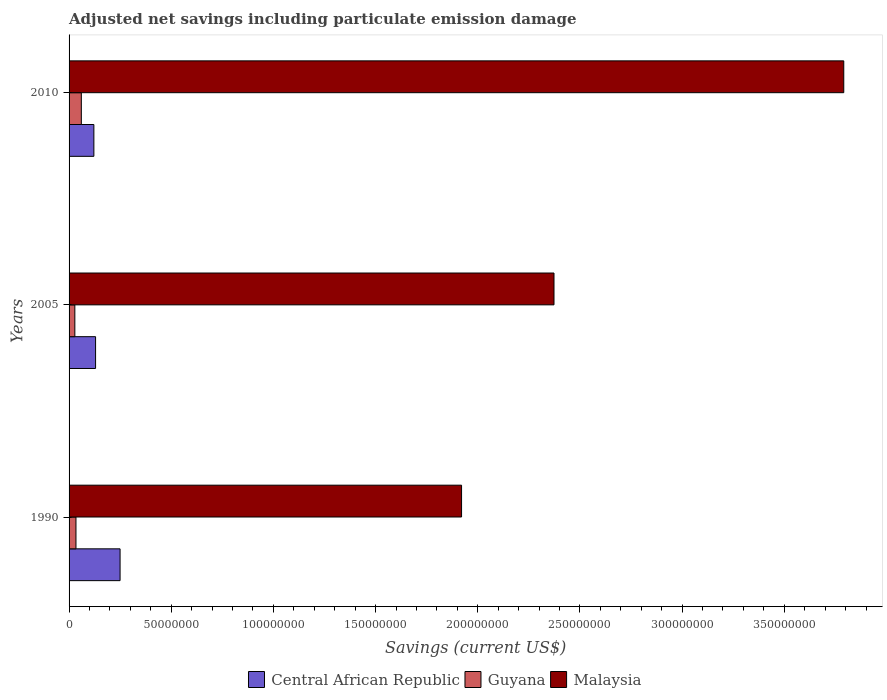How many groups of bars are there?
Your answer should be compact. 3. What is the net savings in Guyana in 2010?
Your answer should be compact. 6.00e+06. Across all years, what is the maximum net savings in Malaysia?
Keep it short and to the point. 3.79e+08. Across all years, what is the minimum net savings in Central African Republic?
Offer a very short reply. 1.21e+07. In which year was the net savings in Guyana minimum?
Offer a terse response. 2005. What is the total net savings in Malaysia in the graph?
Your answer should be very brief. 8.09e+08. What is the difference between the net savings in Central African Republic in 2005 and that in 2010?
Offer a terse response. 8.31e+05. What is the difference between the net savings in Guyana in 1990 and the net savings in Malaysia in 2010?
Offer a terse response. -3.76e+08. What is the average net savings in Guyana per year?
Offer a terse response. 4.07e+06. In the year 1990, what is the difference between the net savings in Guyana and net savings in Central African Republic?
Your answer should be very brief. -2.16e+07. What is the ratio of the net savings in Malaysia in 1990 to that in 2005?
Offer a terse response. 0.81. Is the net savings in Malaysia in 1990 less than that in 2005?
Make the answer very short. Yes. What is the difference between the highest and the second highest net savings in Malaysia?
Your response must be concise. 1.42e+08. What is the difference between the highest and the lowest net savings in Central African Republic?
Your answer should be very brief. 1.28e+07. In how many years, is the net savings in Guyana greater than the average net savings in Guyana taken over all years?
Offer a terse response. 1. Is the sum of the net savings in Malaysia in 2005 and 2010 greater than the maximum net savings in Guyana across all years?
Make the answer very short. Yes. What does the 2nd bar from the top in 2010 represents?
Keep it short and to the point. Guyana. What does the 2nd bar from the bottom in 1990 represents?
Keep it short and to the point. Guyana. Are all the bars in the graph horizontal?
Make the answer very short. Yes. How many years are there in the graph?
Your answer should be compact. 3. What is the difference between two consecutive major ticks on the X-axis?
Give a very brief answer. 5.00e+07. Does the graph contain any zero values?
Ensure brevity in your answer.  No. Does the graph contain grids?
Ensure brevity in your answer.  No. What is the title of the graph?
Your answer should be very brief. Adjusted net savings including particulate emission damage. Does "New Caledonia" appear as one of the legend labels in the graph?
Ensure brevity in your answer.  No. What is the label or title of the X-axis?
Keep it short and to the point. Savings (current US$). What is the label or title of the Y-axis?
Offer a very short reply. Years. What is the Savings (current US$) in Central African Republic in 1990?
Give a very brief answer. 2.50e+07. What is the Savings (current US$) in Guyana in 1990?
Give a very brief answer. 3.37e+06. What is the Savings (current US$) of Malaysia in 1990?
Provide a succinct answer. 1.92e+08. What is the Savings (current US$) in Central African Republic in 2005?
Provide a short and direct response. 1.30e+07. What is the Savings (current US$) in Guyana in 2005?
Keep it short and to the point. 2.82e+06. What is the Savings (current US$) in Malaysia in 2005?
Make the answer very short. 2.37e+08. What is the Savings (current US$) of Central African Republic in 2010?
Give a very brief answer. 1.21e+07. What is the Savings (current US$) of Guyana in 2010?
Your answer should be compact. 6.00e+06. What is the Savings (current US$) in Malaysia in 2010?
Provide a succinct answer. 3.79e+08. Across all years, what is the maximum Savings (current US$) of Central African Republic?
Ensure brevity in your answer.  2.50e+07. Across all years, what is the maximum Savings (current US$) in Guyana?
Give a very brief answer. 6.00e+06. Across all years, what is the maximum Savings (current US$) in Malaysia?
Give a very brief answer. 3.79e+08. Across all years, what is the minimum Savings (current US$) of Central African Republic?
Offer a terse response. 1.21e+07. Across all years, what is the minimum Savings (current US$) of Guyana?
Your answer should be very brief. 2.82e+06. Across all years, what is the minimum Savings (current US$) in Malaysia?
Provide a succinct answer. 1.92e+08. What is the total Savings (current US$) of Central African Republic in the graph?
Offer a very short reply. 5.01e+07. What is the total Savings (current US$) in Guyana in the graph?
Provide a succinct answer. 1.22e+07. What is the total Savings (current US$) in Malaysia in the graph?
Offer a very short reply. 8.09e+08. What is the difference between the Savings (current US$) of Central African Republic in 1990 and that in 2005?
Provide a short and direct response. 1.20e+07. What is the difference between the Savings (current US$) of Guyana in 1990 and that in 2005?
Keep it short and to the point. 5.50e+05. What is the difference between the Savings (current US$) in Malaysia in 1990 and that in 2005?
Keep it short and to the point. -4.52e+07. What is the difference between the Savings (current US$) in Central African Republic in 1990 and that in 2010?
Your answer should be very brief. 1.28e+07. What is the difference between the Savings (current US$) in Guyana in 1990 and that in 2010?
Provide a succinct answer. -2.62e+06. What is the difference between the Savings (current US$) in Malaysia in 1990 and that in 2010?
Your response must be concise. -1.87e+08. What is the difference between the Savings (current US$) of Central African Republic in 2005 and that in 2010?
Provide a short and direct response. 8.31e+05. What is the difference between the Savings (current US$) in Guyana in 2005 and that in 2010?
Your response must be concise. -3.17e+06. What is the difference between the Savings (current US$) of Malaysia in 2005 and that in 2010?
Offer a very short reply. -1.42e+08. What is the difference between the Savings (current US$) of Central African Republic in 1990 and the Savings (current US$) of Guyana in 2005?
Provide a short and direct response. 2.21e+07. What is the difference between the Savings (current US$) of Central African Republic in 1990 and the Savings (current US$) of Malaysia in 2005?
Provide a succinct answer. -2.12e+08. What is the difference between the Savings (current US$) in Guyana in 1990 and the Savings (current US$) in Malaysia in 2005?
Provide a succinct answer. -2.34e+08. What is the difference between the Savings (current US$) in Central African Republic in 1990 and the Savings (current US$) in Guyana in 2010?
Ensure brevity in your answer.  1.90e+07. What is the difference between the Savings (current US$) of Central African Republic in 1990 and the Savings (current US$) of Malaysia in 2010?
Make the answer very short. -3.54e+08. What is the difference between the Savings (current US$) of Guyana in 1990 and the Savings (current US$) of Malaysia in 2010?
Your answer should be compact. -3.76e+08. What is the difference between the Savings (current US$) of Central African Republic in 2005 and the Savings (current US$) of Guyana in 2010?
Offer a terse response. 6.97e+06. What is the difference between the Savings (current US$) in Central African Republic in 2005 and the Savings (current US$) in Malaysia in 2010?
Your answer should be very brief. -3.66e+08. What is the difference between the Savings (current US$) in Guyana in 2005 and the Savings (current US$) in Malaysia in 2010?
Your response must be concise. -3.76e+08. What is the average Savings (current US$) in Central African Republic per year?
Your response must be concise. 1.67e+07. What is the average Savings (current US$) in Guyana per year?
Provide a succinct answer. 4.07e+06. What is the average Savings (current US$) in Malaysia per year?
Offer a very short reply. 2.70e+08. In the year 1990, what is the difference between the Savings (current US$) in Central African Republic and Savings (current US$) in Guyana?
Provide a succinct answer. 2.16e+07. In the year 1990, what is the difference between the Savings (current US$) in Central African Republic and Savings (current US$) in Malaysia?
Ensure brevity in your answer.  -1.67e+08. In the year 1990, what is the difference between the Savings (current US$) in Guyana and Savings (current US$) in Malaysia?
Give a very brief answer. -1.89e+08. In the year 2005, what is the difference between the Savings (current US$) of Central African Republic and Savings (current US$) of Guyana?
Provide a short and direct response. 1.01e+07. In the year 2005, what is the difference between the Savings (current US$) of Central African Republic and Savings (current US$) of Malaysia?
Give a very brief answer. -2.24e+08. In the year 2005, what is the difference between the Savings (current US$) in Guyana and Savings (current US$) in Malaysia?
Provide a succinct answer. -2.34e+08. In the year 2010, what is the difference between the Savings (current US$) of Central African Republic and Savings (current US$) of Guyana?
Make the answer very short. 6.14e+06. In the year 2010, what is the difference between the Savings (current US$) in Central African Republic and Savings (current US$) in Malaysia?
Ensure brevity in your answer.  -3.67e+08. In the year 2010, what is the difference between the Savings (current US$) in Guyana and Savings (current US$) in Malaysia?
Keep it short and to the point. -3.73e+08. What is the ratio of the Savings (current US$) in Central African Republic in 1990 to that in 2005?
Ensure brevity in your answer.  1.92. What is the ratio of the Savings (current US$) in Guyana in 1990 to that in 2005?
Your response must be concise. 1.19. What is the ratio of the Savings (current US$) in Malaysia in 1990 to that in 2005?
Provide a succinct answer. 0.81. What is the ratio of the Savings (current US$) of Central African Republic in 1990 to that in 2010?
Your answer should be compact. 2.06. What is the ratio of the Savings (current US$) in Guyana in 1990 to that in 2010?
Make the answer very short. 0.56. What is the ratio of the Savings (current US$) in Malaysia in 1990 to that in 2010?
Provide a succinct answer. 0.51. What is the ratio of the Savings (current US$) in Central African Republic in 2005 to that in 2010?
Offer a very short reply. 1.07. What is the ratio of the Savings (current US$) of Guyana in 2005 to that in 2010?
Make the answer very short. 0.47. What is the ratio of the Savings (current US$) in Malaysia in 2005 to that in 2010?
Ensure brevity in your answer.  0.63. What is the difference between the highest and the second highest Savings (current US$) of Central African Republic?
Offer a very short reply. 1.20e+07. What is the difference between the highest and the second highest Savings (current US$) in Guyana?
Provide a short and direct response. 2.62e+06. What is the difference between the highest and the second highest Savings (current US$) of Malaysia?
Give a very brief answer. 1.42e+08. What is the difference between the highest and the lowest Savings (current US$) in Central African Republic?
Make the answer very short. 1.28e+07. What is the difference between the highest and the lowest Savings (current US$) of Guyana?
Give a very brief answer. 3.17e+06. What is the difference between the highest and the lowest Savings (current US$) of Malaysia?
Offer a very short reply. 1.87e+08. 